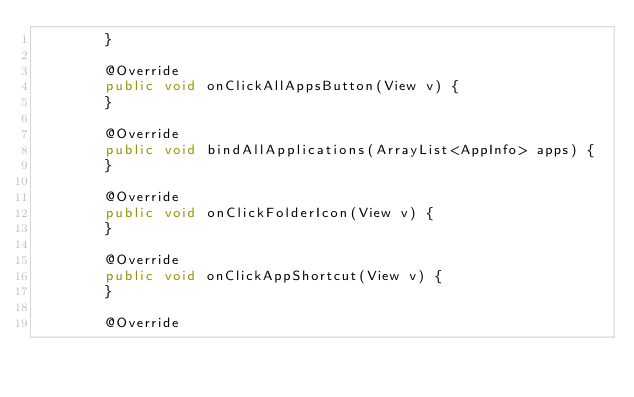Convert code to text. <code><loc_0><loc_0><loc_500><loc_500><_Java_>        }

        @Override
        public void onClickAllAppsButton(View v) {
        }

        @Override
        public void bindAllApplications(ArrayList<AppInfo> apps) {
        }

        @Override
        public void onClickFolderIcon(View v) {
        }

        @Override
        public void onClickAppShortcut(View v) {
        }

        @Override</code> 